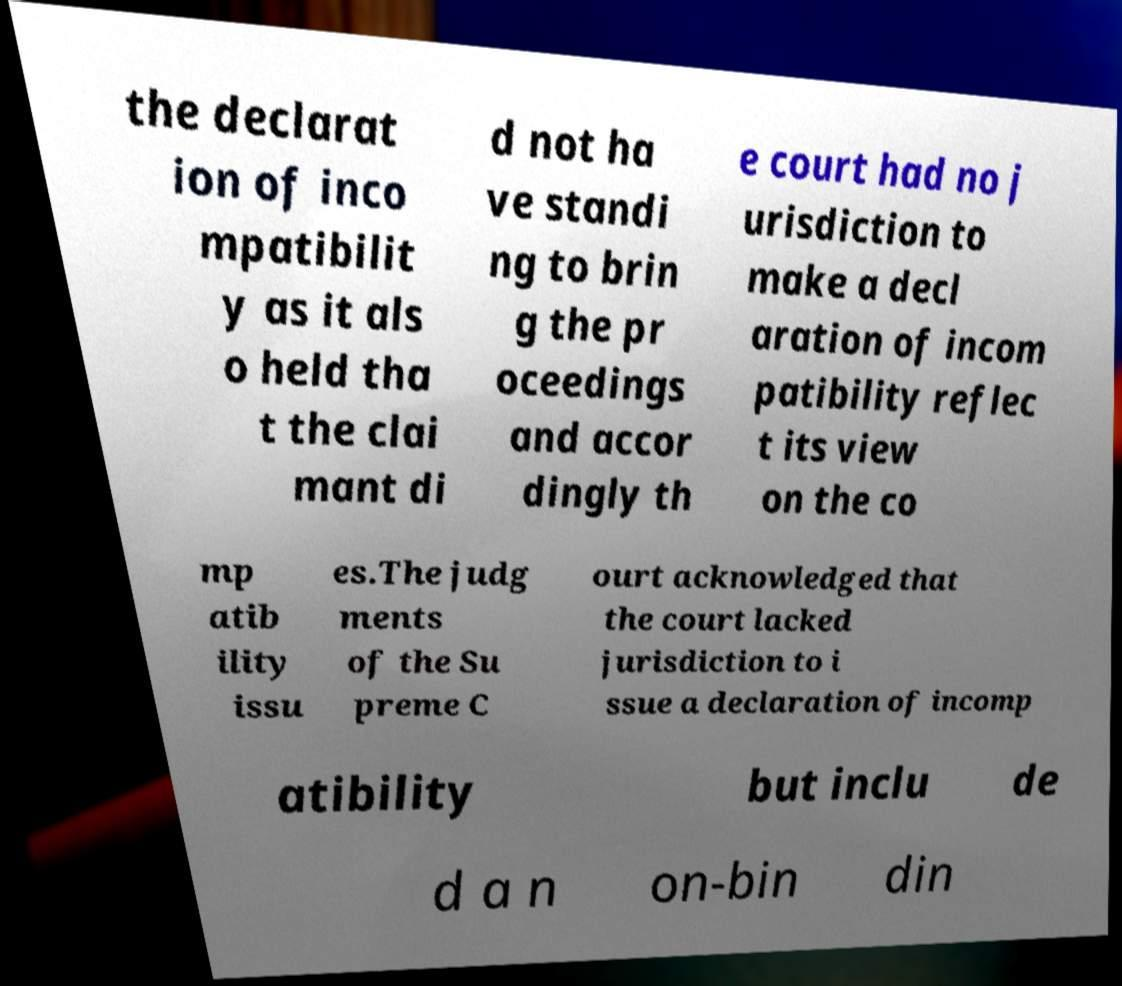Can you read and provide the text displayed in the image?This photo seems to have some interesting text. Can you extract and type it out for me? the declarat ion of inco mpatibilit y as it als o held tha t the clai mant di d not ha ve standi ng to brin g the pr oceedings and accor dingly th e court had no j urisdiction to make a decl aration of incom patibility reflec t its view on the co mp atib ility issu es.The judg ments of the Su preme C ourt acknowledged that the court lacked jurisdiction to i ssue a declaration of incomp atibility but inclu de d a n on-bin din 